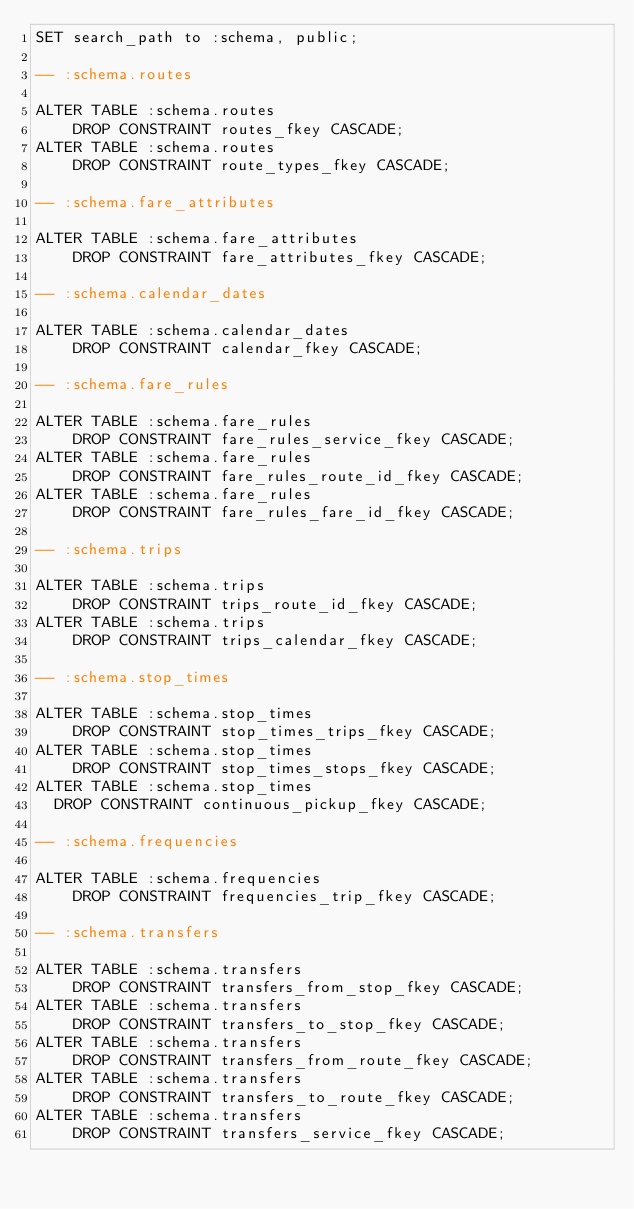<code> <loc_0><loc_0><loc_500><loc_500><_SQL_>SET search_path to :schema, public;

-- :schema.routes

ALTER TABLE :schema.routes
    DROP CONSTRAINT routes_fkey CASCADE;
ALTER TABLE :schema.routes
    DROP CONSTRAINT route_types_fkey CASCADE;

-- :schema.fare_attributes

ALTER TABLE :schema.fare_attributes
    DROP CONSTRAINT fare_attributes_fkey CASCADE;

-- :schema.calendar_dates

ALTER TABLE :schema.calendar_dates
    DROP CONSTRAINT calendar_fkey CASCADE;

-- :schema.fare_rules

ALTER TABLE :schema.fare_rules
    DROP CONSTRAINT fare_rules_service_fkey CASCADE;
ALTER TABLE :schema.fare_rules
    DROP CONSTRAINT fare_rules_route_id_fkey CASCADE;
ALTER TABLE :schema.fare_rules
    DROP CONSTRAINT fare_rules_fare_id_fkey CASCADE;

-- :schema.trips

ALTER TABLE :schema.trips
    DROP CONSTRAINT trips_route_id_fkey CASCADE;
ALTER TABLE :schema.trips
    DROP CONSTRAINT trips_calendar_fkey CASCADE;

-- :schema.stop_times

ALTER TABLE :schema.stop_times
    DROP CONSTRAINT stop_times_trips_fkey CASCADE;
ALTER TABLE :schema.stop_times
    DROP CONSTRAINT stop_times_stops_fkey CASCADE;
ALTER TABLE :schema.stop_times
  DROP CONSTRAINT continuous_pickup_fkey CASCADE;

-- :schema.frequencies

ALTER TABLE :schema.frequencies
    DROP CONSTRAINT frequencies_trip_fkey CASCADE;

-- :schema.transfers

ALTER TABLE :schema.transfers
    DROP CONSTRAINT transfers_from_stop_fkey CASCADE;
ALTER TABLE :schema.transfers
    DROP CONSTRAINT transfers_to_stop_fkey CASCADE;
ALTER TABLE :schema.transfers
    DROP CONSTRAINT transfers_from_route_fkey CASCADE;
ALTER TABLE :schema.transfers
    DROP CONSTRAINT transfers_to_route_fkey CASCADE;
ALTER TABLE :schema.transfers
    DROP CONSTRAINT transfers_service_fkey CASCADE;
</code> 